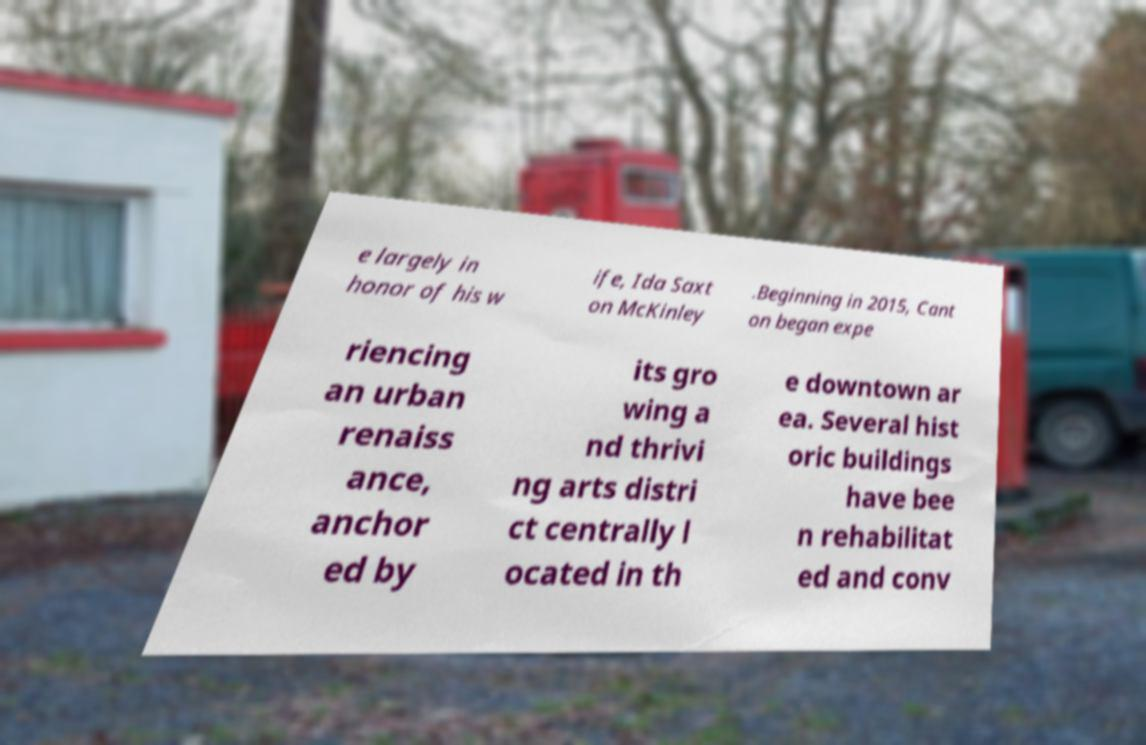For documentation purposes, I need the text within this image transcribed. Could you provide that? e largely in honor of his w ife, Ida Saxt on McKinley .Beginning in 2015, Cant on began expe riencing an urban renaiss ance, anchor ed by its gro wing a nd thrivi ng arts distri ct centrally l ocated in th e downtown ar ea. Several hist oric buildings have bee n rehabilitat ed and conv 